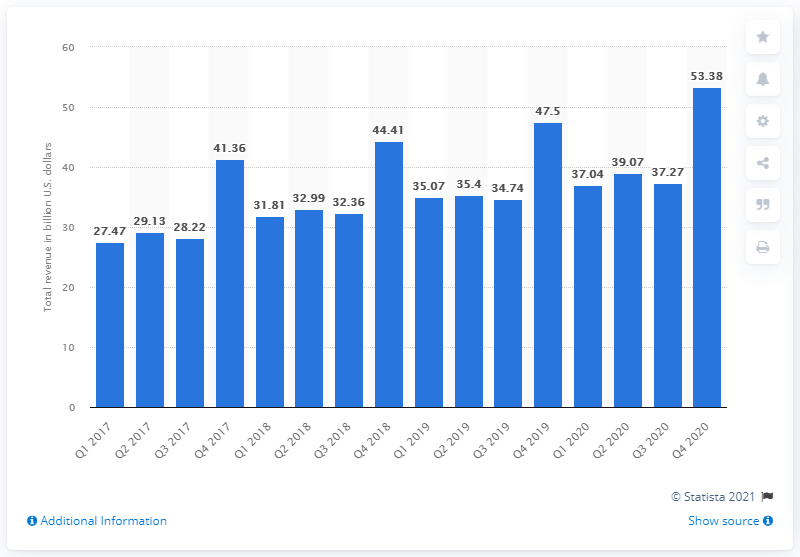Indicate a few pertinent items in this graphic. In the fourth quarter of 2020, Costco generated revenue totaling $53.38 billion. 